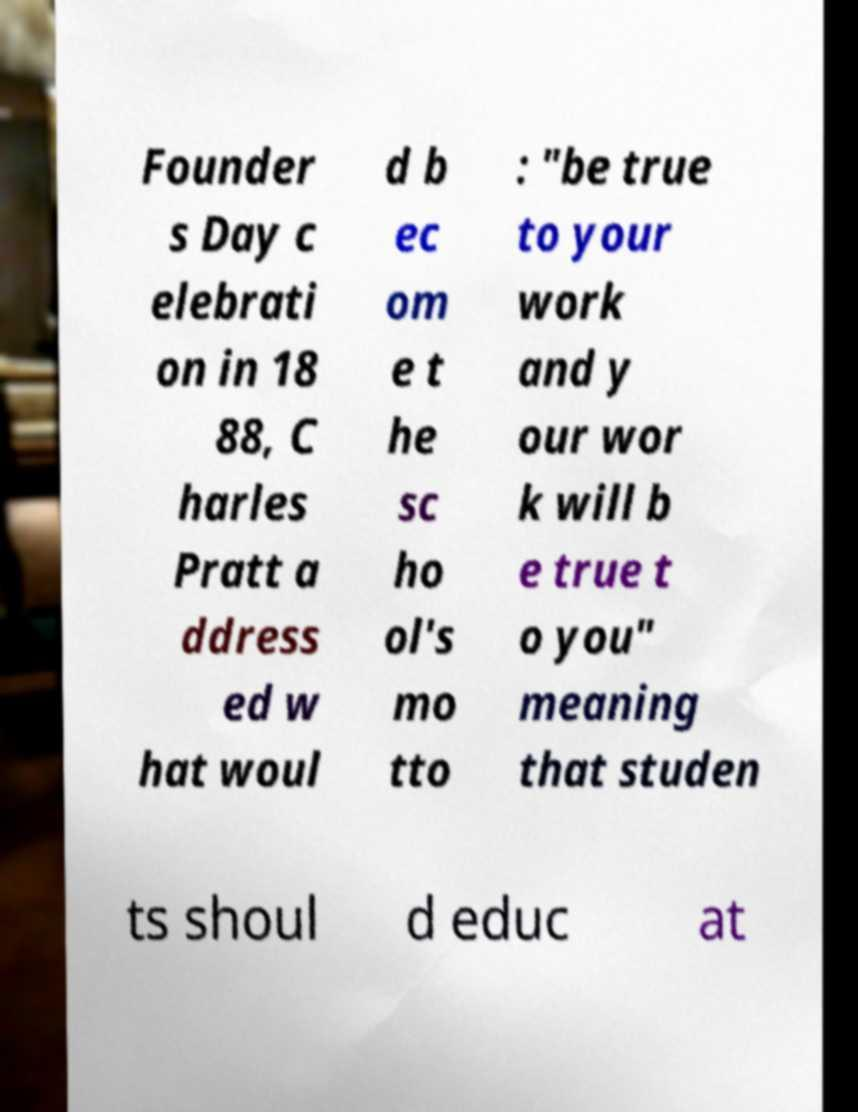Could you extract and type out the text from this image? Founder s Day c elebrati on in 18 88, C harles Pratt a ddress ed w hat woul d b ec om e t he sc ho ol's mo tto : "be true to your work and y our wor k will b e true t o you" meaning that studen ts shoul d educ at 